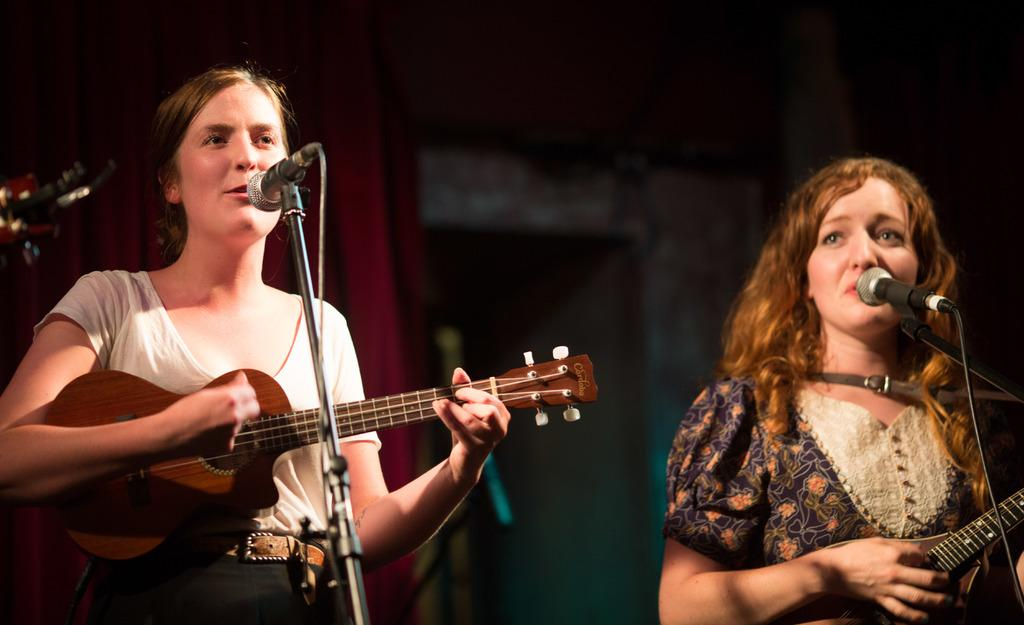How many people are in the image? There are two people in the image. Where are the people located in the image? Both people are standing on a stage. What are the people doing in the image? Both people are playing musical instruments. How many cards are being used by the people in the image? There are no cards present in the image; both people are playing musical instruments. 